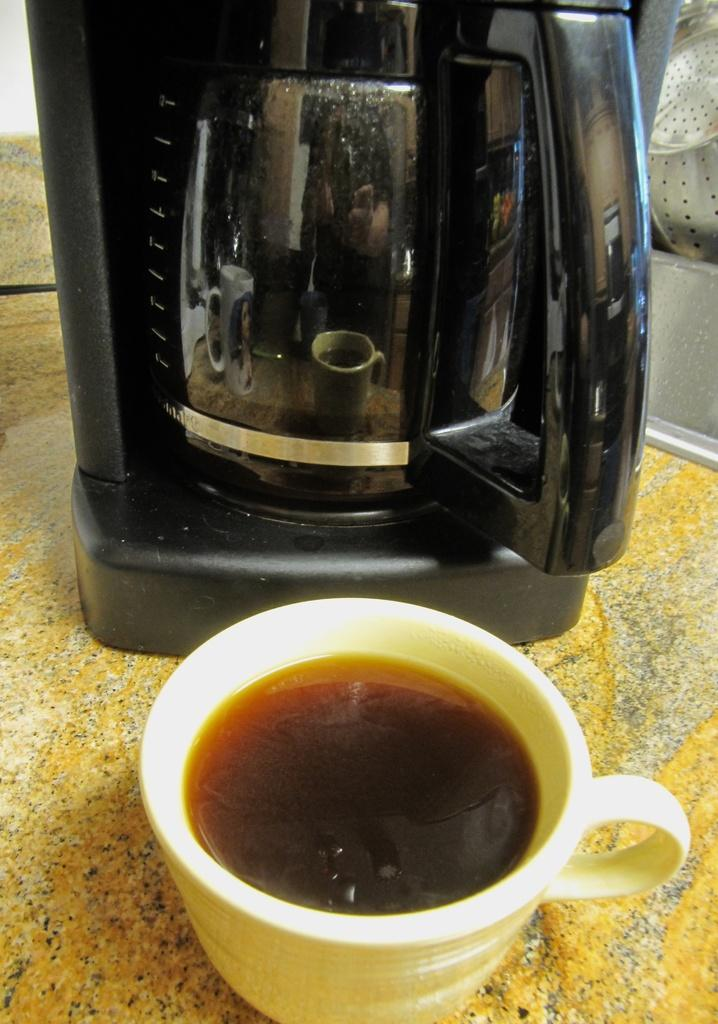What is one object visible in the image? There is a coffee cup in the image. What other object can be seen in the image? There is a kettle in the image. Where are the coffee cup and the kettle located in the image? Both the coffee cup and the kettle are on a surface. What type of loaf is present in the image? There is no loaf present in the image. 